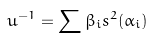<formula> <loc_0><loc_0><loc_500><loc_500>u ^ { - 1 } = \sum \beta _ { i } s ^ { 2 } ( \alpha _ { i } )</formula> 